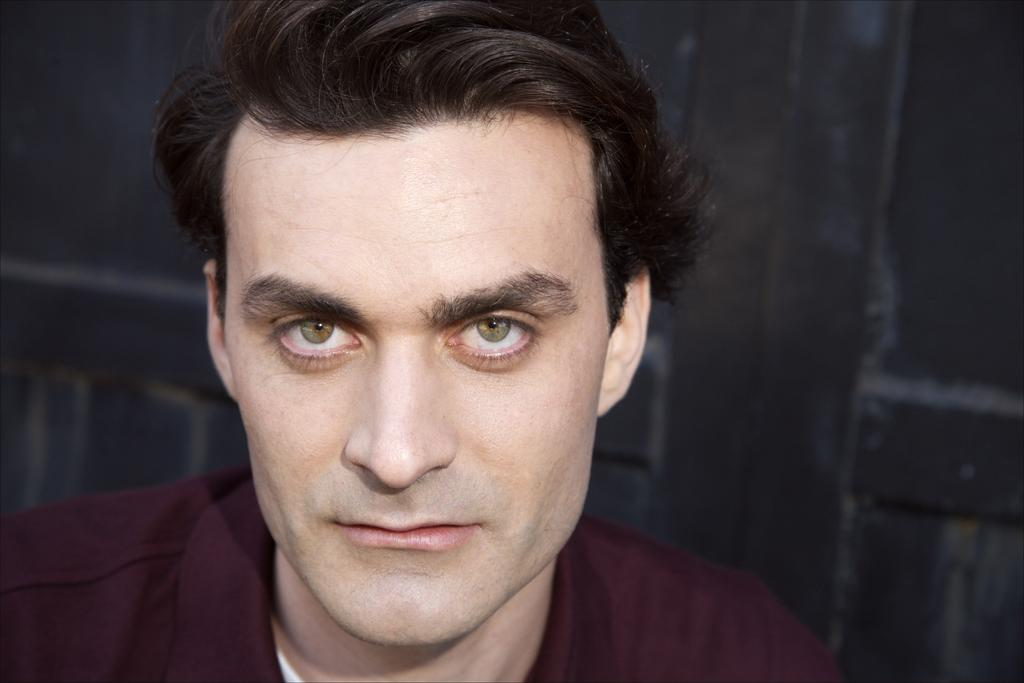What is the main subject of the image? There is a man in the image. How many fingers does the man have on his left hand in the image? The image does not provide enough information to determine the number of fingers the man has on his left hand. 